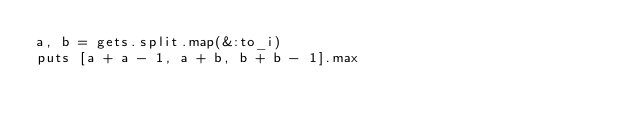Convert code to text. <code><loc_0><loc_0><loc_500><loc_500><_Ruby_>a, b = gets.split.map(&:to_i)
puts [a + a - 1, a + b, b + b - 1].max
</code> 